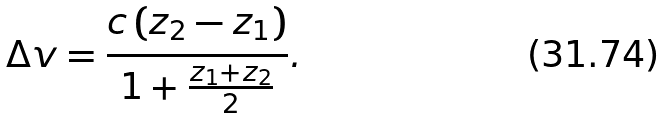Convert formula to latex. <formula><loc_0><loc_0><loc_500><loc_500>\Delta v = \frac { c \, ( z _ { 2 } - z _ { 1 } ) } { 1 + \frac { z _ { 1 } + z _ { 2 } } { 2 } } .</formula> 